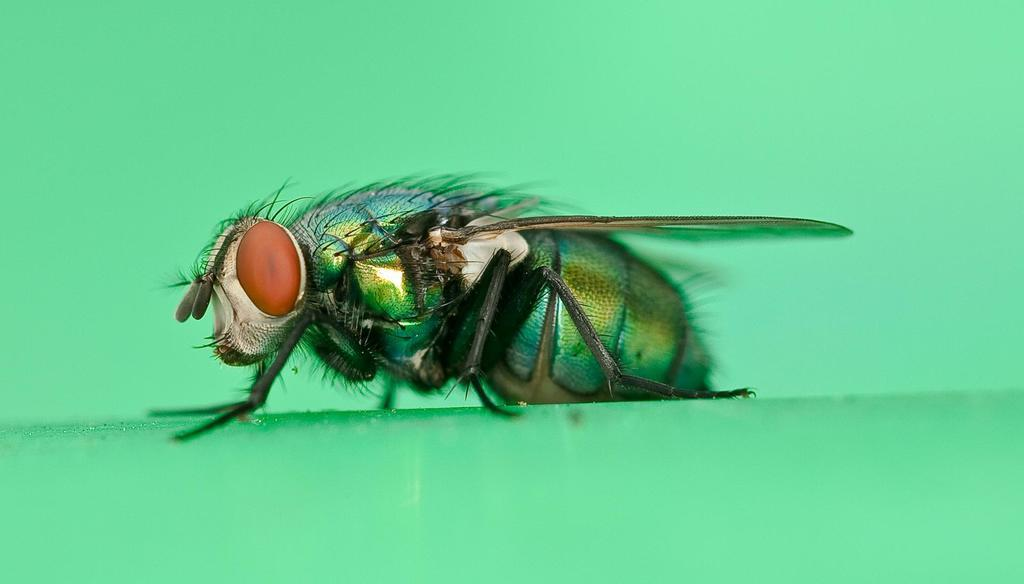What is the main subject of the image? The main subject of the image is a fly. Can you describe the fly's appearance? The fly has orange-colored eyes, legs, and wings. Where is the fly located in the image? The fly is on a green-colored surface. What is the color of the background in the image? The background of the image is green in color. How many sisters does the fly have in the image? There are no sisters mentioned or depicted in the image, as it features a fly with no other subjects. 